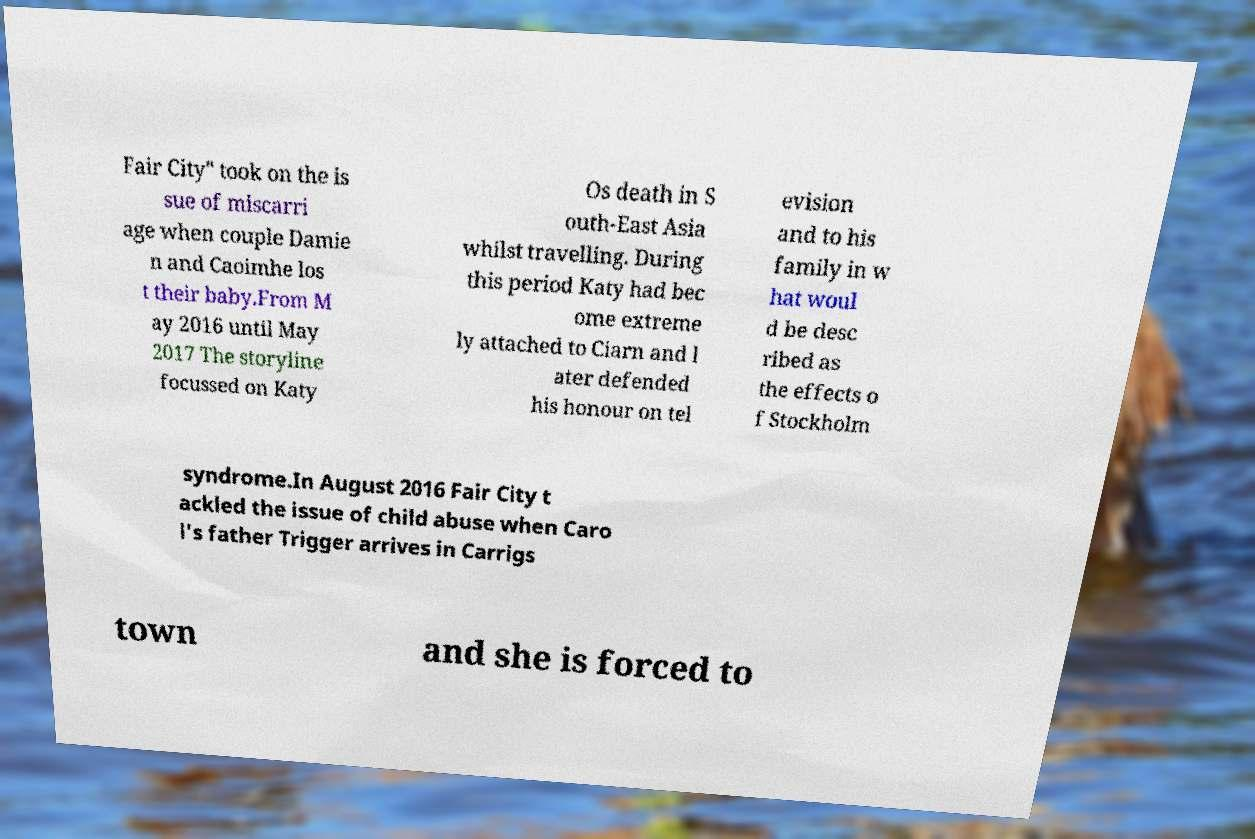There's text embedded in this image that I need extracted. Can you transcribe it verbatim? Fair City" took on the is sue of miscarri age when couple Damie n and Caoimhe los t their baby.From M ay 2016 until May 2017 The storyline focussed on Katy Os death in S outh-East Asia whilst travelling. During this period Katy had bec ome extreme ly attached to Ciarn and l ater defended his honour on tel evision and to his family in w hat woul d be desc ribed as the effects o f Stockholm syndrome.In August 2016 Fair City t ackled the issue of child abuse when Caro l's father Trigger arrives in Carrigs town and she is forced to 